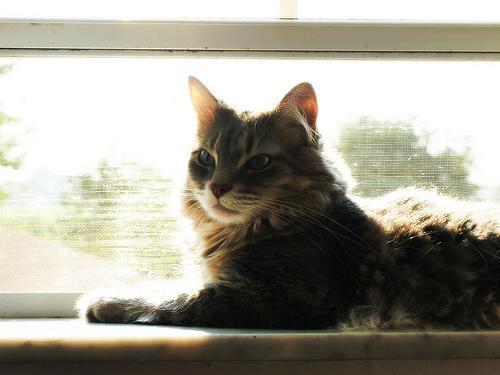How many cats are pictured?
Give a very brief answer. 1. 